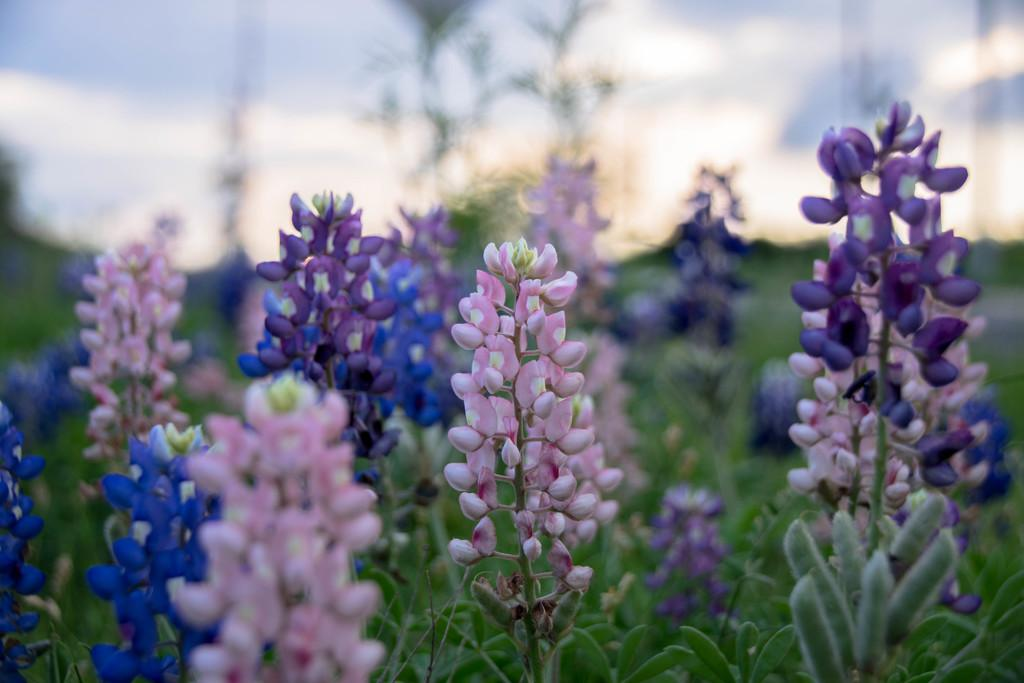What type of living organisms can be seen in the image? There are flowers on plants in the image. Can you describe the plants in the image? The plants in the image have flowers on them. What type of straw can be seen in the image? There is no straw present in the image; it features flowers on plants. What position is the nut in the image? There is no nut present in the image; it only shows flowers on plants. 